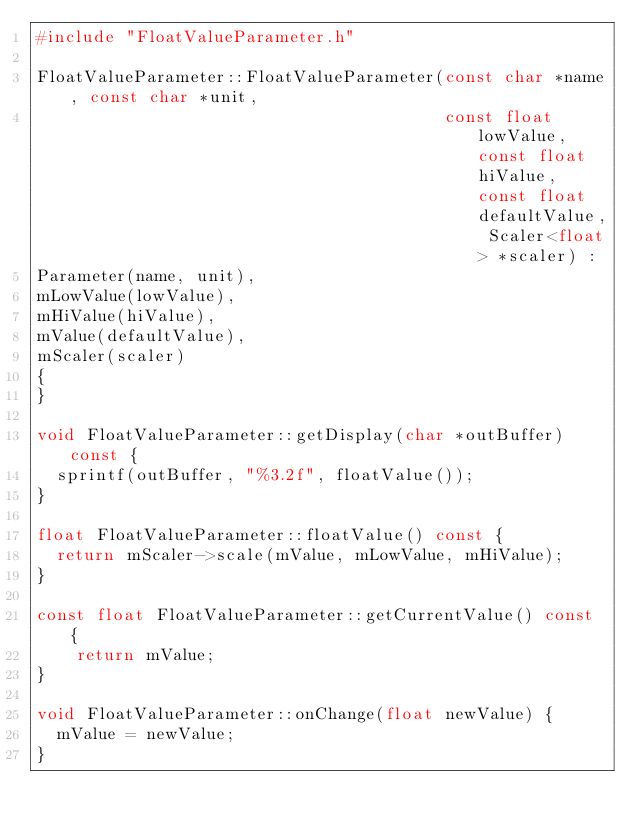Convert code to text. <code><loc_0><loc_0><loc_500><loc_500><_C++_>#include "FloatValueParameter.h"

FloatValueParameter::FloatValueParameter(const char *name, const char *unit,
                                         const float lowValue, const float hiValue, const float defaultValue, Scaler<float> *scaler) :
Parameter(name, unit),
mLowValue(lowValue),
mHiValue(hiValue),
mValue(defaultValue),
mScaler(scaler)
{
}

void FloatValueParameter::getDisplay(char *outBuffer) const {
  sprintf(outBuffer, "%3.2f", floatValue());
}

float FloatValueParameter::floatValue() const {
  return mScaler->scale(mValue, mLowValue, mHiValue);
}

const float FloatValueParameter::getCurrentValue() const {
	return mValue;
}

void FloatValueParameter::onChange(float newValue) {
  mValue = newValue;
}</code> 